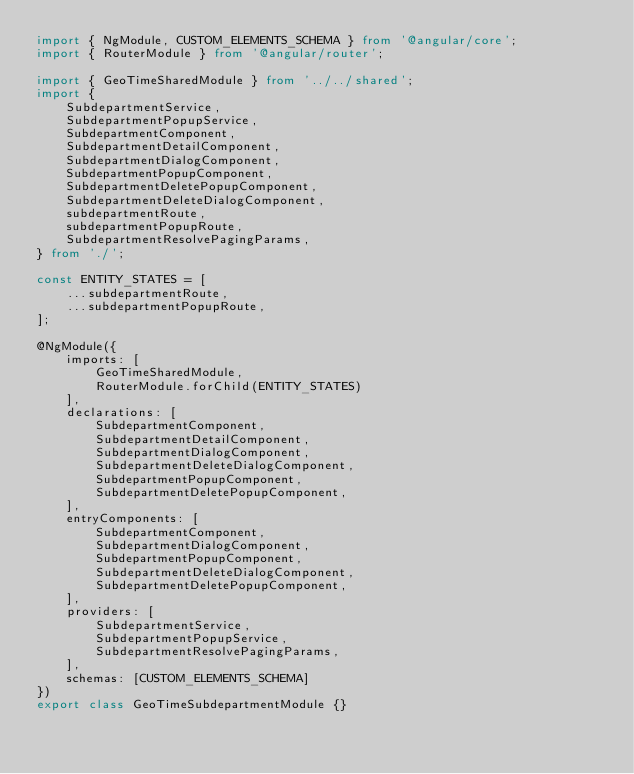<code> <loc_0><loc_0><loc_500><loc_500><_TypeScript_>import { NgModule, CUSTOM_ELEMENTS_SCHEMA } from '@angular/core';
import { RouterModule } from '@angular/router';

import { GeoTimeSharedModule } from '../../shared';
import {
    SubdepartmentService,
    SubdepartmentPopupService,
    SubdepartmentComponent,
    SubdepartmentDetailComponent,
    SubdepartmentDialogComponent,
    SubdepartmentPopupComponent,
    SubdepartmentDeletePopupComponent,
    SubdepartmentDeleteDialogComponent,
    subdepartmentRoute,
    subdepartmentPopupRoute,
    SubdepartmentResolvePagingParams,
} from './';

const ENTITY_STATES = [
    ...subdepartmentRoute,
    ...subdepartmentPopupRoute,
];

@NgModule({
    imports: [
        GeoTimeSharedModule,
        RouterModule.forChild(ENTITY_STATES)
    ],
    declarations: [
        SubdepartmentComponent,
        SubdepartmentDetailComponent,
        SubdepartmentDialogComponent,
        SubdepartmentDeleteDialogComponent,
        SubdepartmentPopupComponent,
        SubdepartmentDeletePopupComponent,
    ],
    entryComponents: [
        SubdepartmentComponent,
        SubdepartmentDialogComponent,
        SubdepartmentPopupComponent,
        SubdepartmentDeleteDialogComponent,
        SubdepartmentDeletePopupComponent,
    ],
    providers: [
        SubdepartmentService,
        SubdepartmentPopupService,
        SubdepartmentResolvePagingParams,
    ],
    schemas: [CUSTOM_ELEMENTS_SCHEMA]
})
export class GeoTimeSubdepartmentModule {}
</code> 